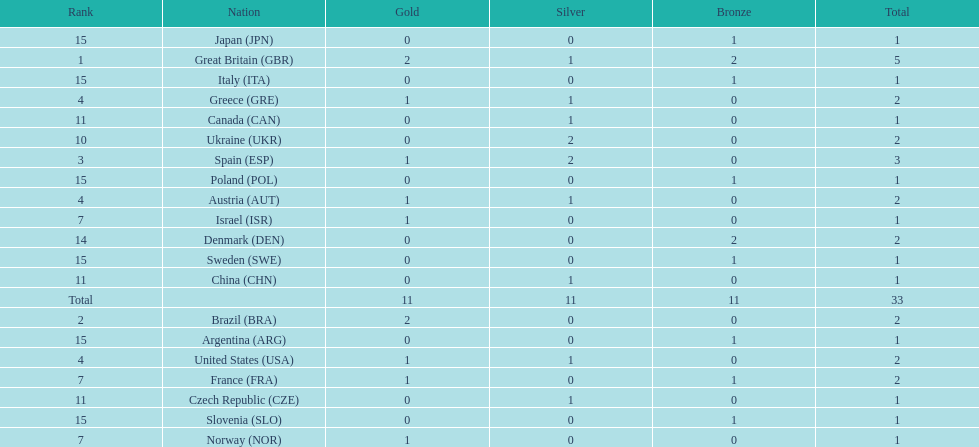What was the total number of medals won by united states? 2. Parse the table in full. {'header': ['Rank', 'Nation', 'Gold', 'Silver', 'Bronze', 'Total'], 'rows': [['15', 'Japan\xa0(JPN)', '0', '0', '1', '1'], ['1', 'Great Britain\xa0(GBR)', '2', '1', '2', '5'], ['15', 'Italy\xa0(ITA)', '0', '0', '1', '1'], ['4', 'Greece\xa0(GRE)', '1', '1', '0', '2'], ['11', 'Canada\xa0(CAN)', '0', '1', '0', '1'], ['10', 'Ukraine\xa0(UKR)', '0', '2', '0', '2'], ['3', 'Spain\xa0(ESP)', '1', '2', '0', '3'], ['15', 'Poland\xa0(POL)', '0', '0', '1', '1'], ['4', 'Austria\xa0(AUT)', '1', '1', '0', '2'], ['7', 'Israel\xa0(ISR)', '1', '0', '0', '1'], ['14', 'Denmark\xa0(DEN)', '0', '0', '2', '2'], ['15', 'Sweden\xa0(SWE)', '0', '0', '1', '1'], ['11', 'China\xa0(CHN)', '0', '1', '0', '1'], ['Total', '', '11', '11', '11', '33'], ['2', 'Brazil\xa0(BRA)', '2', '0', '0', '2'], ['15', 'Argentina\xa0(ARG)', '0', '0', '1', '1'], ['4', 'United States\xa0(USA)', '1', '1', '0', '2'], ['7', 'France\xa0(FRA)', '1', '0', '1', '2'], ['11', 'Czech Republic\xa0(CZE)', '0', '1', '0', '1'], ['15', 'Slovenia\xa0(SLO)', '0', '0', '1', '1'], ['7', 'Norway\xa0(NOR)', '1', '0', '0', '1']]} 